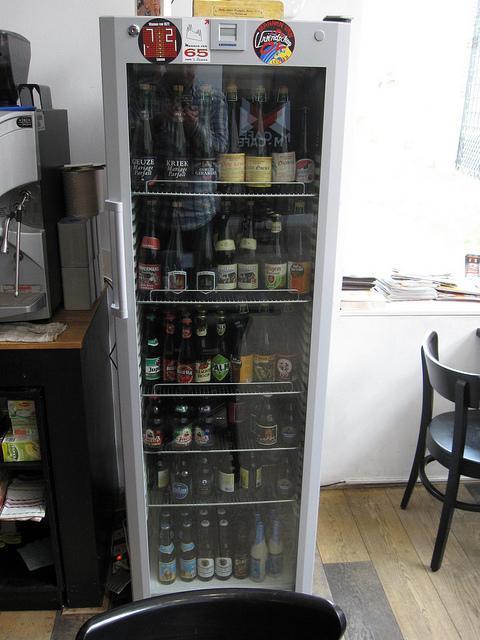What drink has the owner of this cooler stocked up on?
Select the accurate response from the four choices given to answer the question.
Options: Beer, soda, water, wine. Water. 